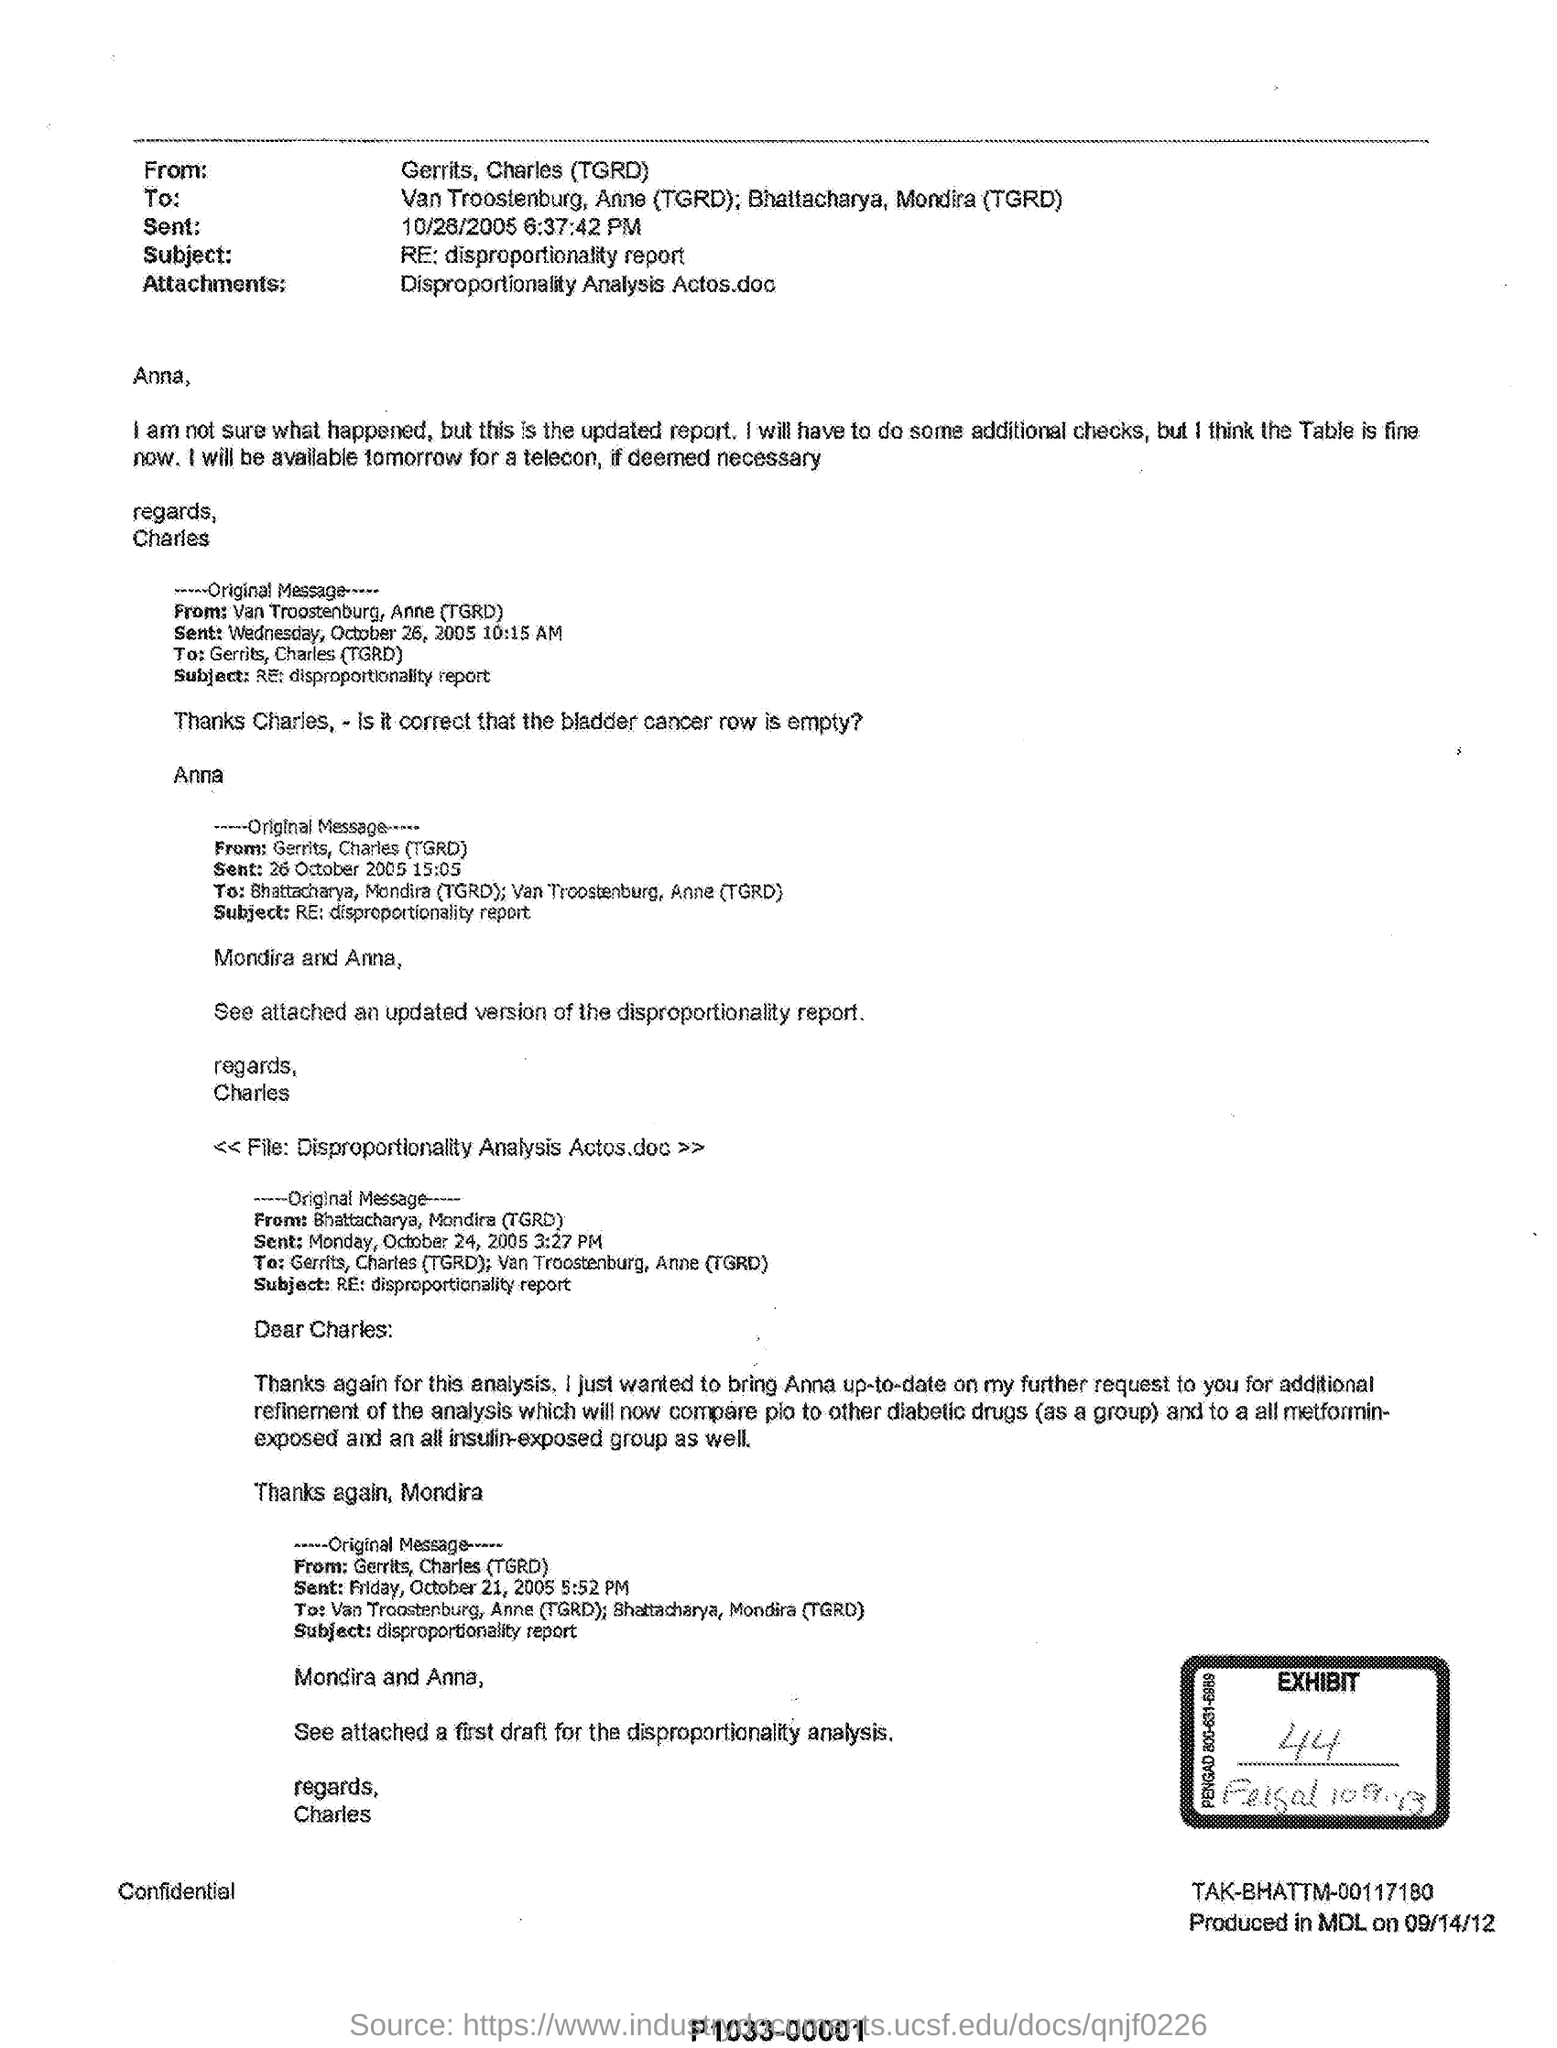When will i be available for telecon if deemed necessary
Your answer should be very brief. Tomorrow. Which version of disproportionality report was attached
Provide a succinct answer. An updated version. Which report is mentioned in the subject
Provide a succinct answer. Disproportionality report. 